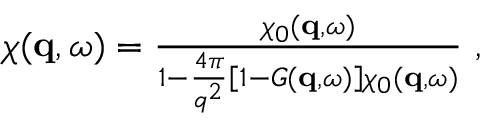Convert formula to latex. <formula><loc_0><loc_0><loc_500><loc_500>\begin{array} { r } { \chi ( q , \omega ) = \frac { \chi _ { 0 } ( q , \omega ) } { 1 - \frac { 4 \pi } { q ^ { 2 } } \left [ 1 - G ( q , \omega ) \right ] \chi _ { 0 } ( q , \omega ) } \ , } \end{array}</formula> 